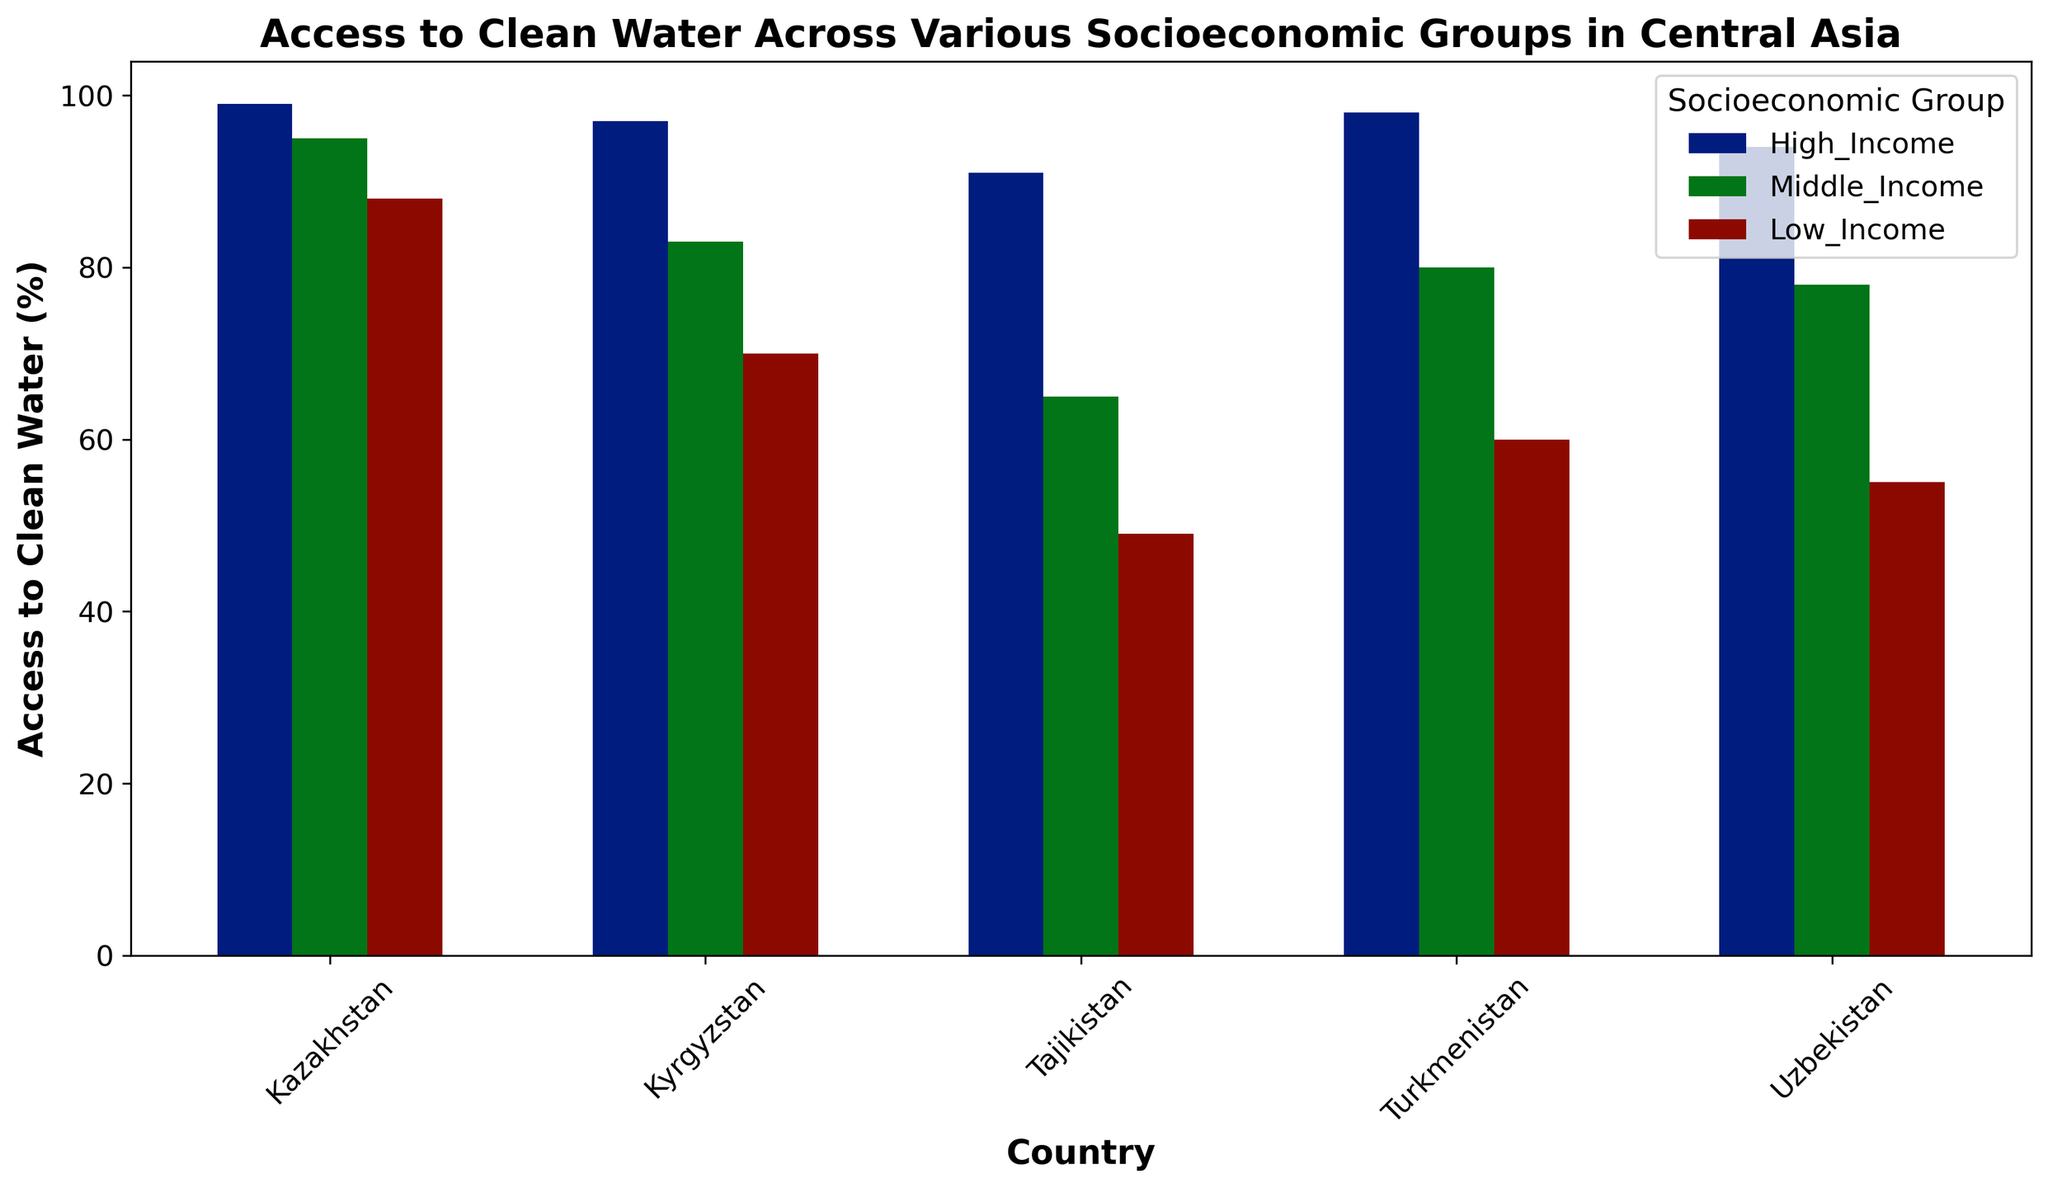What's the percentage difference in access to clean water between the high and low-income groups in Tajikistan? To find the percentage difference, subtract the percentage of the low-income group from the high-income group: 91% - 49% = 42%
Answer: 42% Which socioeconomic group has the highest access to clean water in Uzbekistan? From the bar chart, it is evident that the high-income group has the highest access to clean water in Uzbekistan with 94%
Answer: High_Income Compare the access to clean water between high-income groups in Kazakhstan and Kyrgyzstan. Which country has better access, and by how much? The high-income group in Kazakhstan has 99% access while in Kyrgyzstan it is 97%. The difference is 99% - 97% = 2%
Answer: Kazakhstan by 2% What's the average access to clean water percentage across all socioeconomic groups in Turkmenistan? Add the percentages of all three groups in Turkmenistan and divide by 3: (98% + 80% + 60%) / 3 = 79.33%
Answer: 79.33% Which country shows the largest gap between high and low-income groups in terms of access to clean water? Calculate the gap for each country: Kazakhstan (99% - 88% = 11%), Kyrgyzstan (97% - 70% = 27%), Tajikistan (91% - 49% = 42%), Turkmenistan (98% - 60% = 38%), Uzbekistan (94% - 55% = 39%). Tajikistan has the largest gap: 42%
Answer: Tajikistan How does the access to clean water for middle-income groups compare across all countries? Which country has the highest access for this group? By examining the middle-income group's bars, we can see the access percentages: Kazakhstan (95%), Kyrgyzstan (83%), Tajikistan (65%), Turkmenistan (80%), Uzbekistan (78%). Kazakhstan has the highest access for the middle-income group with 95%
Answer: Kazakhstan What's the total sum of access to clean water percentages for all socioeconomic groups in Kazakhstan? Sum the access percentages for all three groups in Kazakhstan: 99% + 95% + 88% = 282%
Answer: 282% In which country does the low-income group have the least access to clean water, and what is the percentage? By identifying the lowest bar for the low-income groups, Tajikistan has the least access with 49%
Answer: Tajikistan with 49% Look at the colors representing different socioeconomic groups. What visual attribute helps differentiate them in the bar chart? The bars for different socioeconomic groups are differentiated by distinct colors, making it easy to identify each group visually
Answer: Colors 